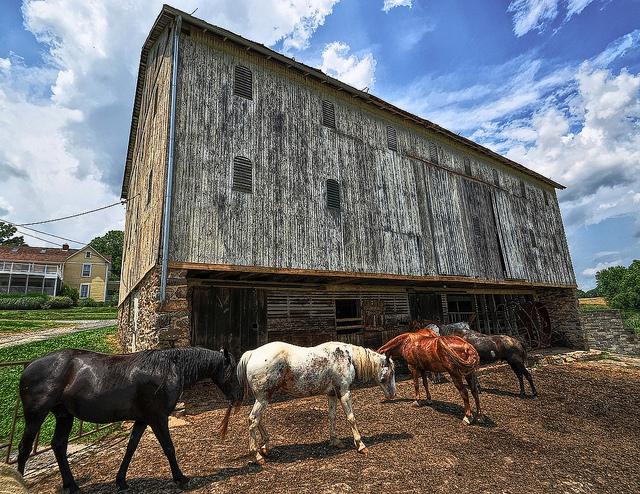How many horses are there?
Keep it brief. 4. Is the barn old?
Answer briefly. Yes. Where is the white horse?
Keep it brief. Middle. How many houses are there?
Keep it brief. 1. 